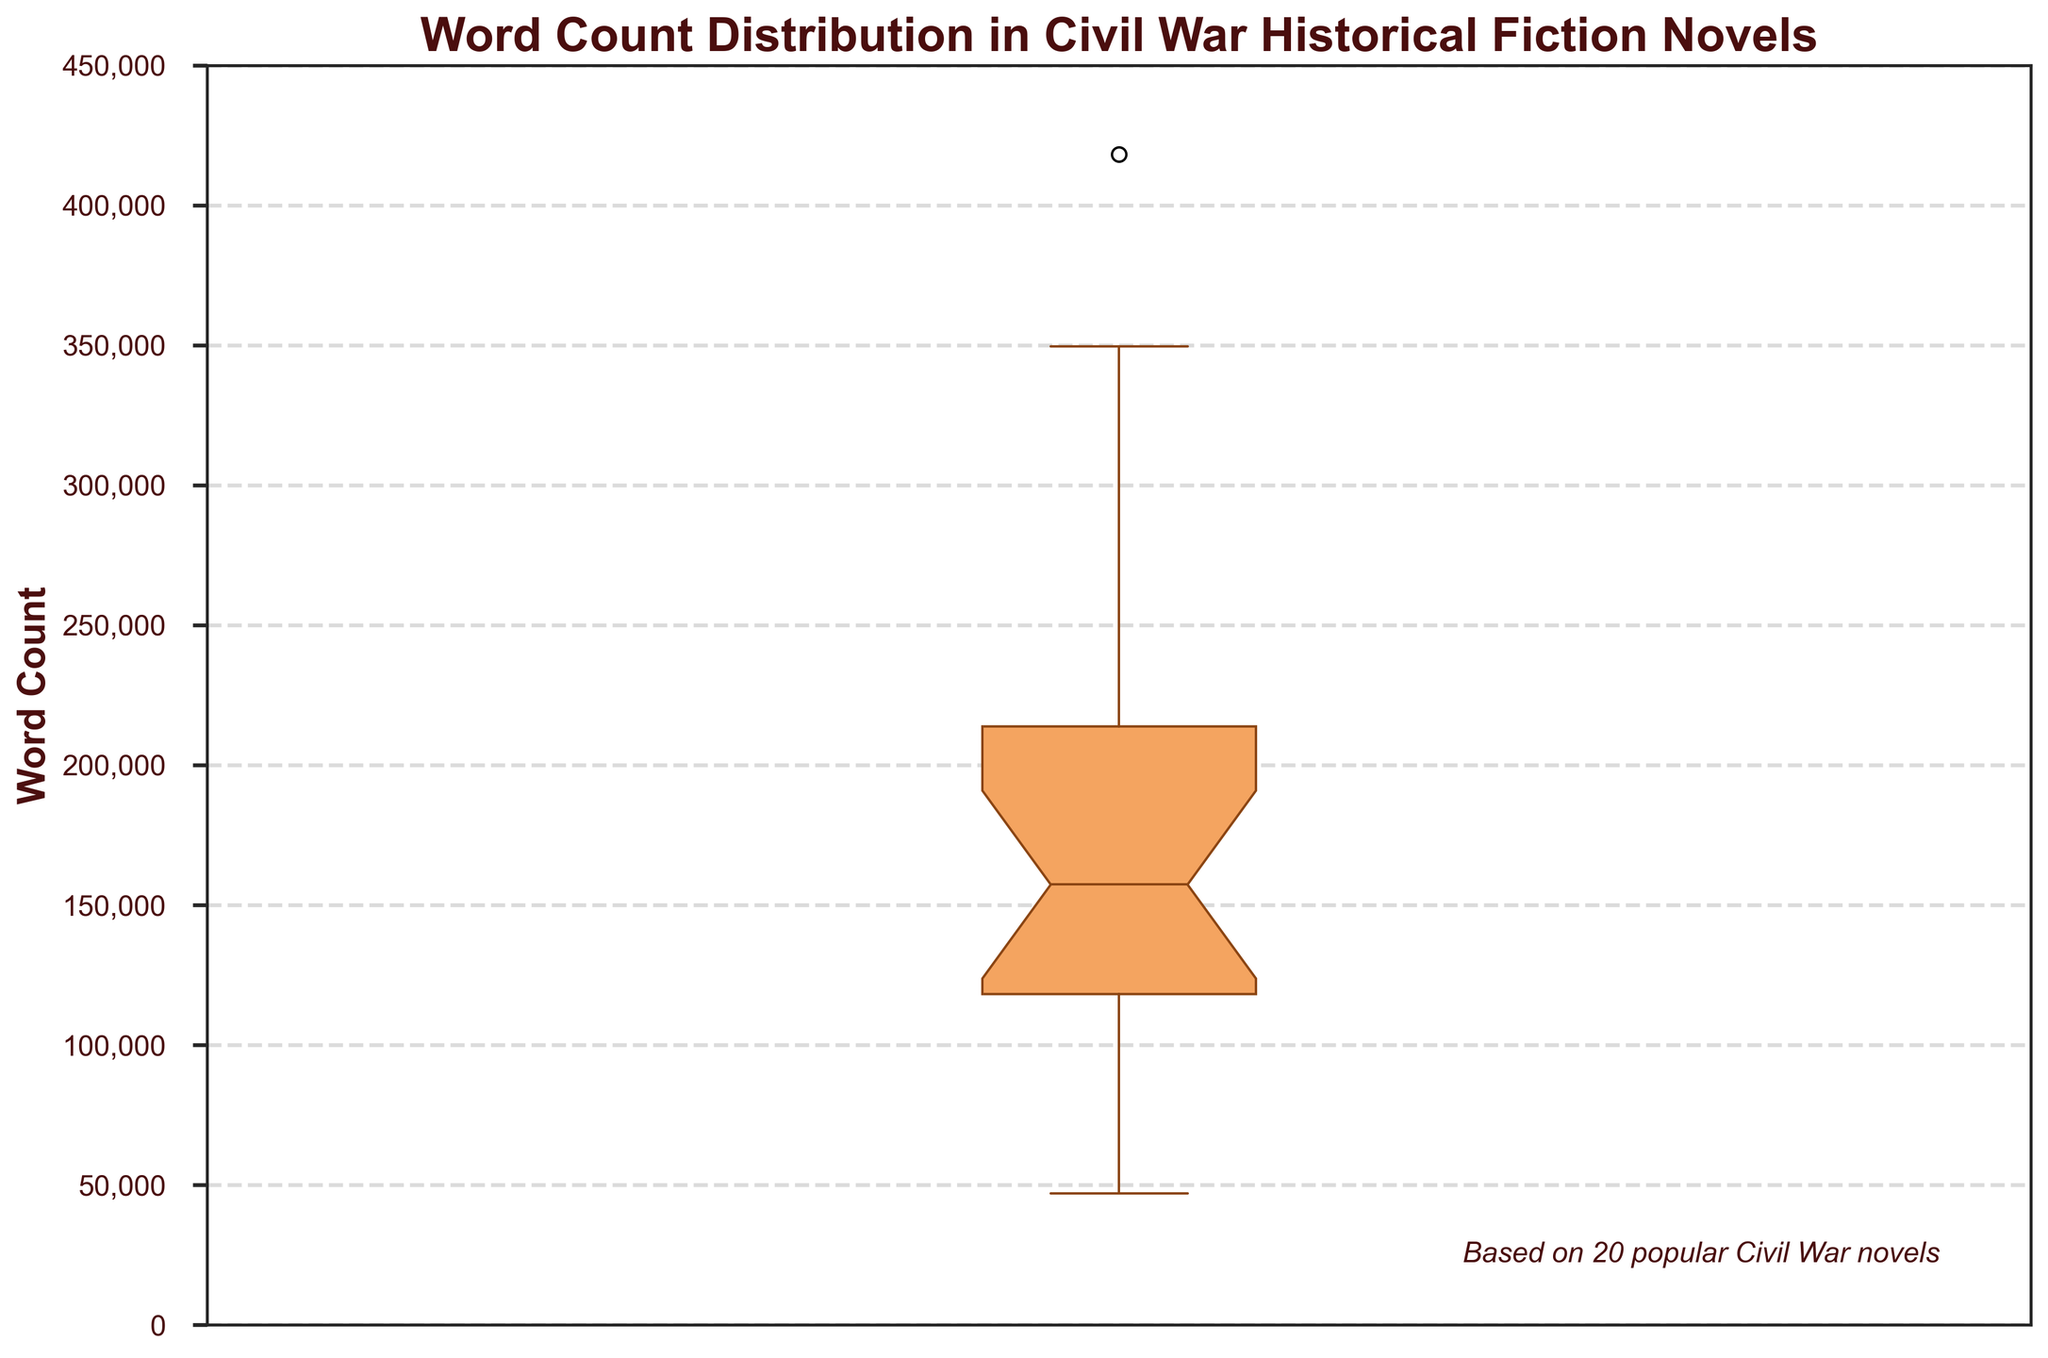What is the title of the plot? The title is usually found at the top of the figure. For this plot, the title reads "Word Count Distribution in Civil War Historical Fiction Novels".
Answer: Word Count Distribution in Civil War Historical Fiction Novels What does the y-axis represent? The axis labels describe what each axis measures. The y-axis label for this figure is "Word Count".
Answer: Word Count What is the range of the y-axis? The y-axis range can be determined by the minimum and maximum values shown on the axis. The y-axis starts at 0 and goes up to 450,000.
Answer: 0 to 450,000 Around what value is the median word count? The median is represented by the line inside the box of the box plot. Visually, the median appears to be slightly below 200,000.
Answer: Slightly below 200,000 What is the lower quartile (Q1) value for the word count distribution? The lower quartile or Q1 is represented by the bottom edge of the box in a box plot. Q1 appears to be around 100,000.
Answer: Around 100,000 What is the upper quartile (Q3) value for the word count distribution? The upper quartile or Q3 is represented by the top edge of the box in a box plot. Q3 appears to be around 225,000.
Answer: Around 225,000 What does the notch in the box plot indicate? The notch in a box plot represents the confidence interval around the median and helps in visually assessing if the medians of different groups are significantly different.
Answer: Confidence interval around the median Where is the interquartile range (IQR) on the plot, and what does it represent? The IQR is represented by the length of the box in the box plot, stretching from Q1 to Q3. It represents the middle 50% of the data, indicating the range within which the central half of the word count data lies.
Answer: Between Q1 and Q3 What is the maximum word count displayed as the upper whisker range? The upper whisker represents the maximum value within 1.5 times the IQR from Q3. The upper whisker seems to extend to around 350,000.
Answer: Around 350,000 Which novel has the highest word count, and what is it? The fliers or outliers in the plot represent values outside the whiskers. The outlier at the top of the plot would point to the novel with the highest word count, "Gone with the Wind", with 418,053 words.
Answer: "Gone with the Wind", 418,053 